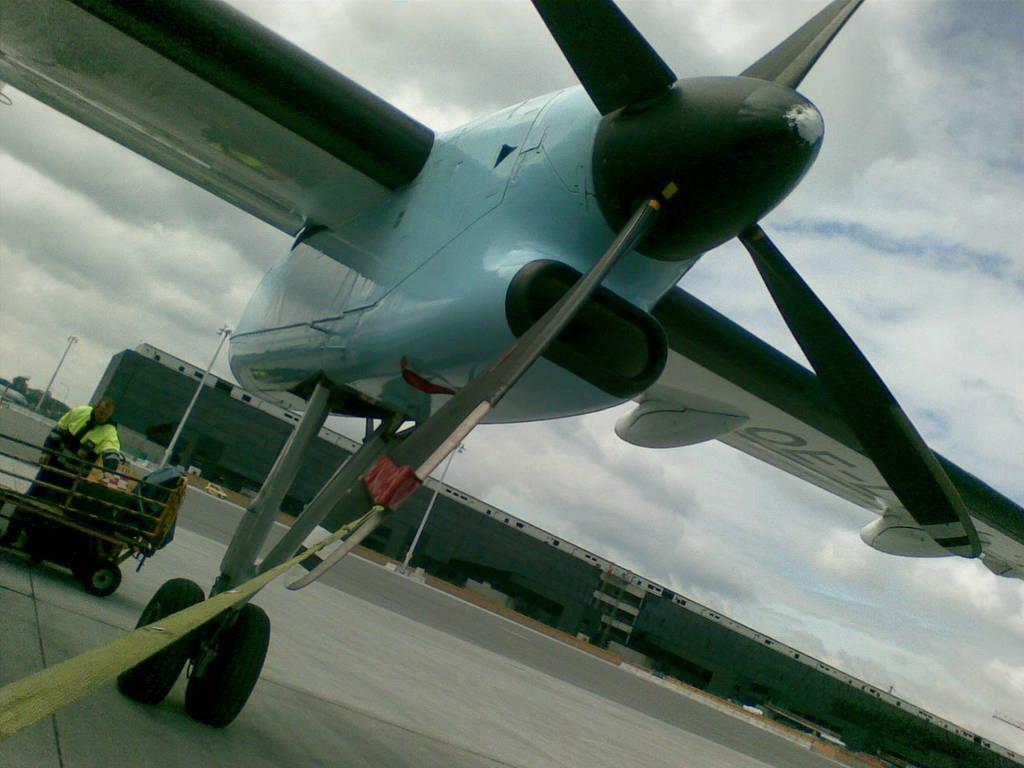Please provide a concise description of this image. Here we can see a plane on the road and on the left side there is a man standing on the road at the cart. In the background there are buildings,poles,trees,glass doors,vehicles on the ground and clouds in the sky. 